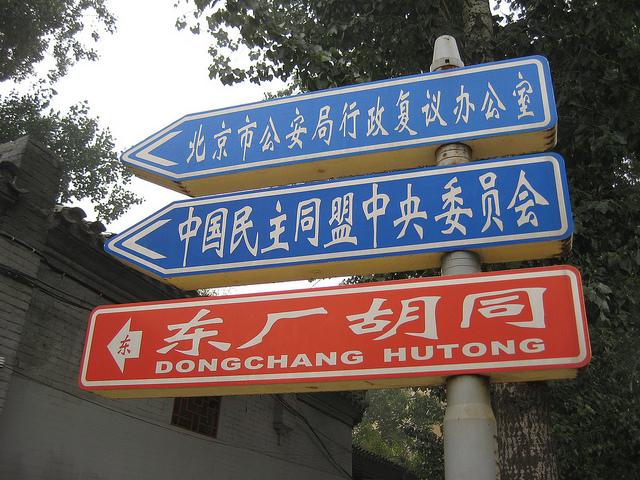What color is the sign?
Concise answer only. Blue and red. What does the sign say?
Keep it brief. Dongchang hutong. What color is the bottom sign?
Write a very short answer. Red. Are there buildings on this building?
Short answer required. No. Are these signs in mainland China, or Taiwan?
Be succinct. China. What language is the sign in?
Short answer required. Chinese. What city is at the next left?
Quick response, please. Dongchang hutong. 